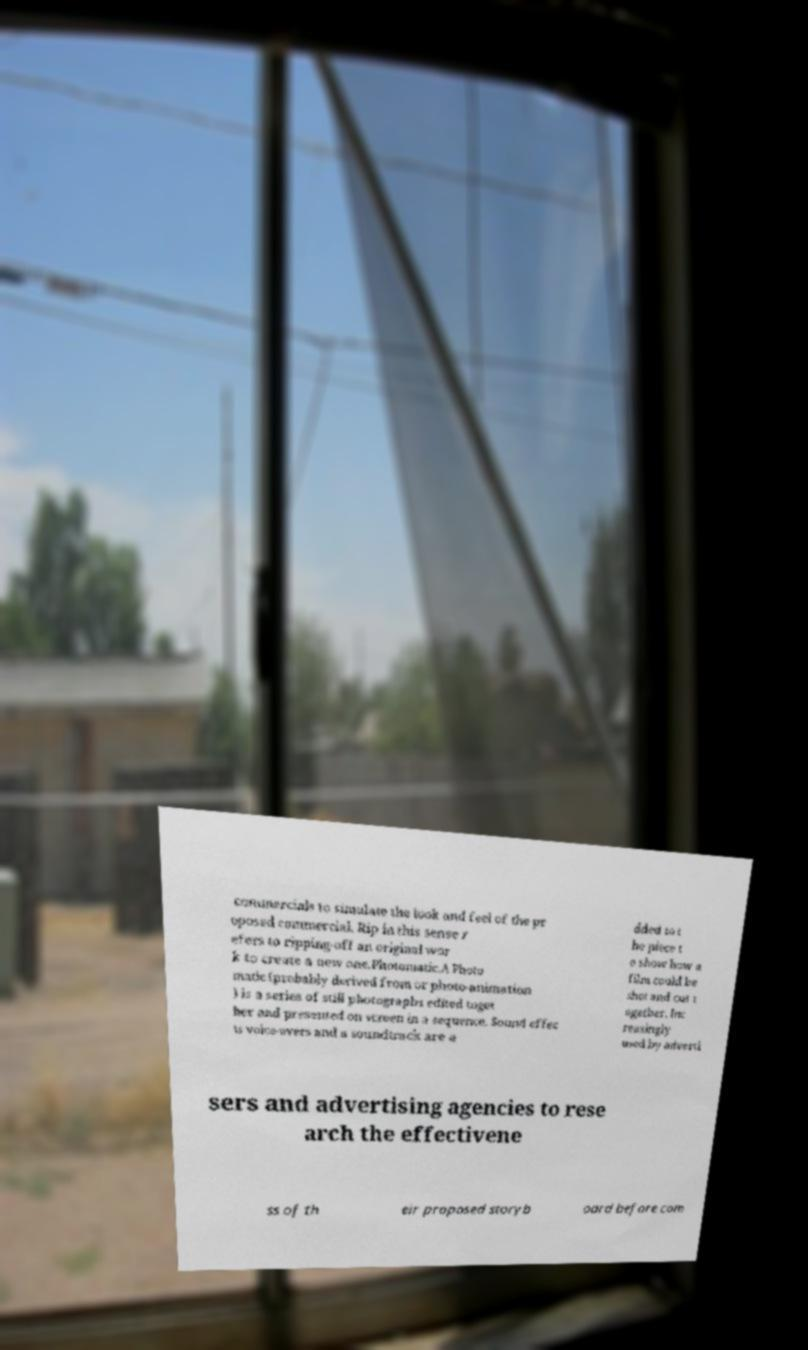There's text embedded in this image that I need extracted. Can you transcribe it verbatim? commercials to simulate the look and feel of the pr oposed commercial. Rip in this sense r efers to ripping-off an original wor k to create a new one.Photomatic.A Photo matic (probably derived from or photo-animation ) is a series of still photographs edited toget her and presented on screen in a sequence. Sound effec ts voice-overs and a soundtrack are a dded to t he piece t o show how a film could be shot and cut t ogether. Inc reasingly used by adverti sers and advertising agencies to rese arch the effectivene ss of th eir proposed storyb oard before com 